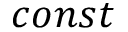Convert formula to latex. <formula><loc_0><loc_0><loc_500><loc_500>c o n s t</formula> 